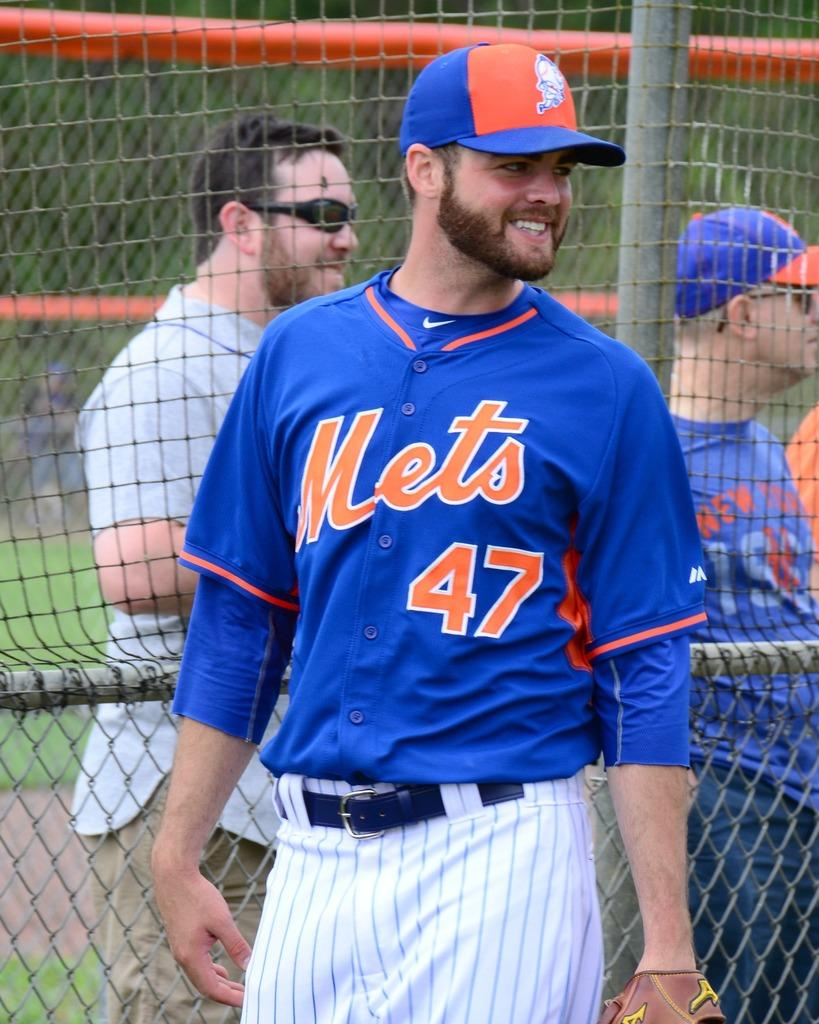<image>
Present a compact description of the photo's key features. A baseball player, number 47 for the Mets, has a glove on his left hand. 